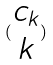Convert formula to latex. <formula><loc_0><loc_0><loc_500><loc_500>( \begin{matrix} c _ { k } \\ k \end{matrix} )</formula> 